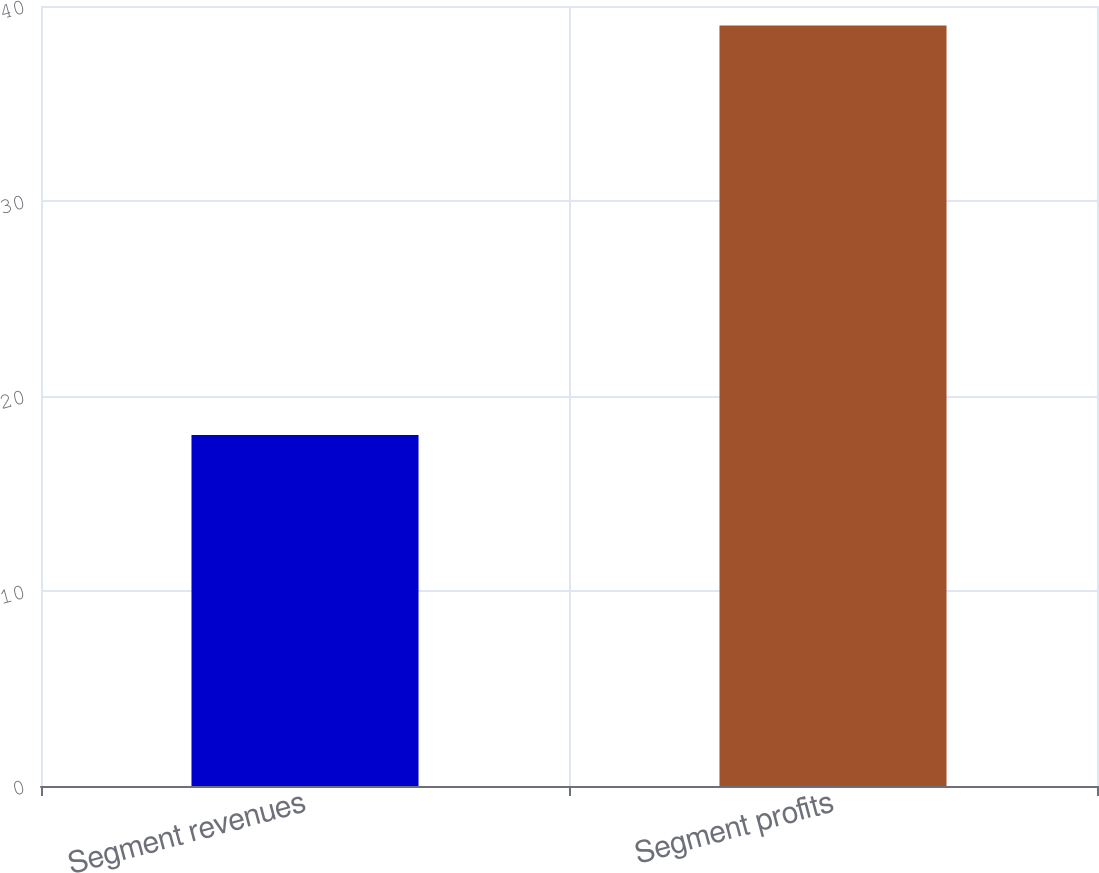Convert chart. <chart><loc_0><loc_0><loc_500><loc_500><bar_chart><fcel>Segment revenues<fcel>Segment profits<nl><fcel>18<fcel>39<nl></chart> 